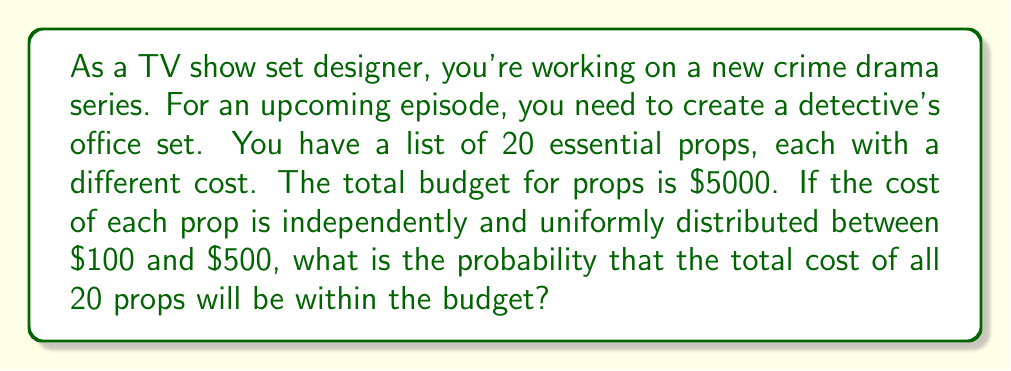Can you solve this math problem? To solve this problem, we'll use the Central Limit Theorem and approximate the distribution of the total cost as a normal distribution.

1. First, let's calculate the mean and variance of the cost for a single prop:

   Mean: $\mu = \frac{100 + 500}{2} = 300$
   
   Variance: $\sigma^2 = \frac{(500 - 100)^2}{12} = \frac{400^2}{12} = 13333.33$

2. For 20 props, the mean and variance of the total cost will be:

   Mean of total: $\mu_{total} = 20 \times 300 = 6000$
   
   Variance of total: $\sigma_{total}^2 = 20 \times 13333.33 = 266666.67$
   
   Standard deviation of total: $\sigma_{total} = \sqrt{266666.67} = 516.40$

3. We want to find $P(X \leq 5000)$ where $X$ is the total cost.

4. Standardizing the random variable:

   $Z = \frac{X - \mu_{total}}{\sigma_{total}} = \frac{5000 - 6000}{516.40} = -1.94$

5. Using the standard normal distribution table or calculator, we can find:

   $P(Z \leq -1.94) = 0.0262$

This means the probability that the total cost is less than or equal to $5000 is approximately 0.0262 or 2.62%.
Answer: The probability that the total cost of all 20 props will be within the budget of $5000 is approximately 0.0262 or 2.62%. 